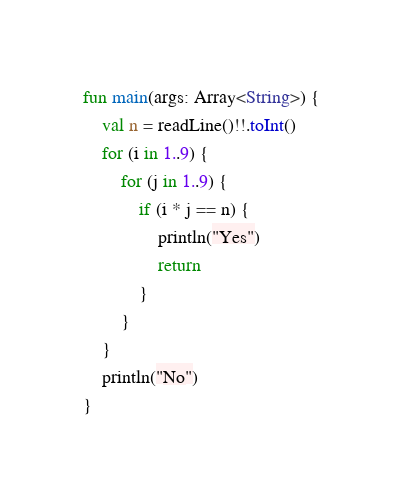Convert code to text. <code><loc_0><loc_0><loc_500><loc_500><_Kotlin_>fun main(args: Array<String>) {
    val n = readLine()!!.toInt()
    for (i in 1..9) {
        for (j in 1..9) {
            if (i * j == n) {
                println("Yes")
                return
            }
        }
    }
    println("No")
}</code> 